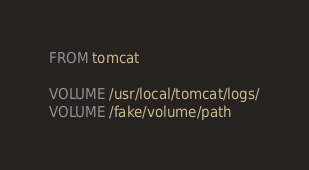Convert code to text. <code><loc_0><loc_0><loc_500><loc_500><_Dockerfile_>FROM tomcat

VOLUME /usr/local/tomcat/logs/
VOLUME /fake/volume/path
</code> 